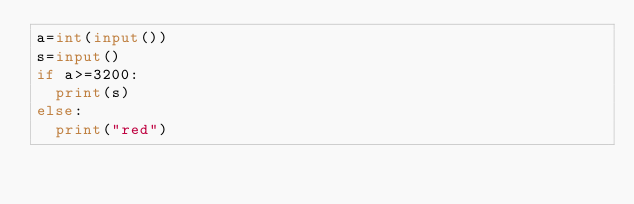Convert code to text. <code><loc_0><loc_0><loc_500><loc_500><_Python_>a=int(input())
s=input()
if a>=3200:
  print(s)
else:
  print("red")
</code> 